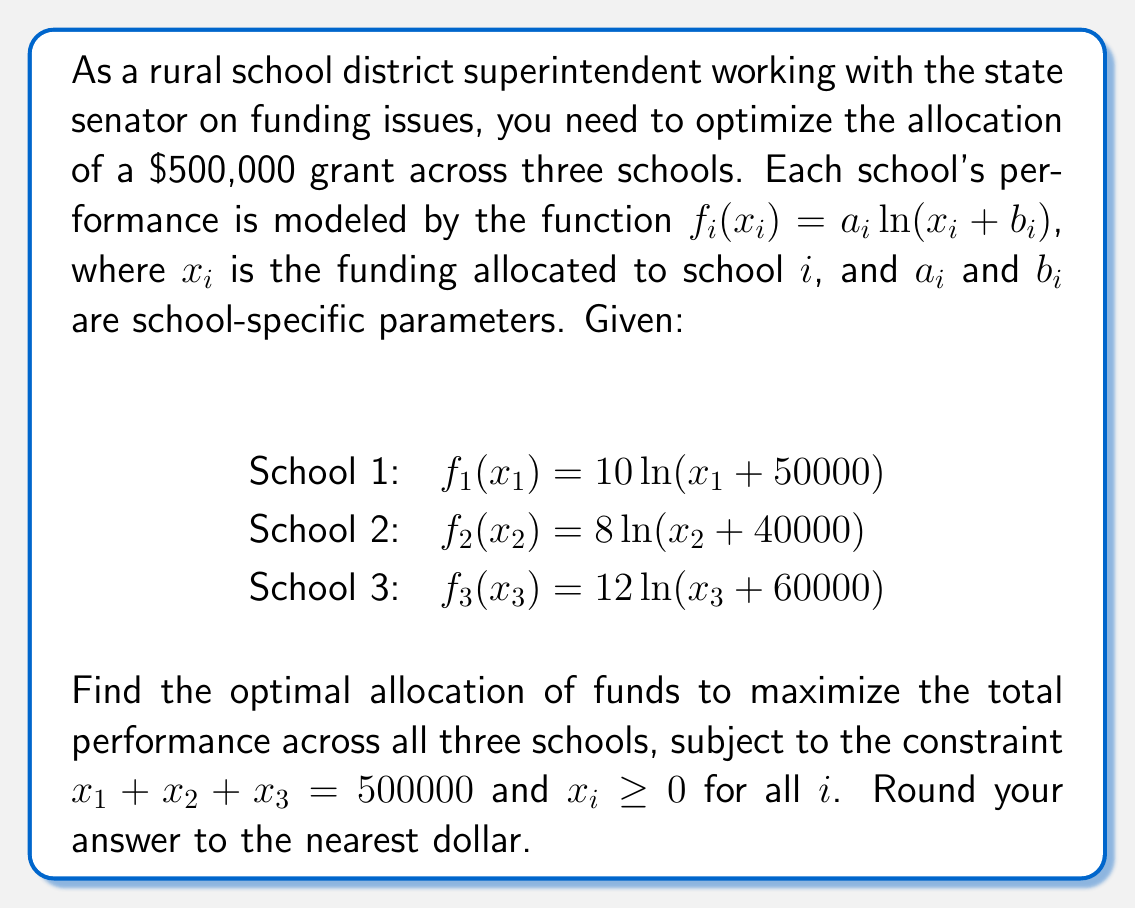Give your solution to this math problem. To solve this optimization problem, we'll use the method of Lagrange multipliers:

1) Let's define our objective function:
   $$F(x_1, x_2, x_3) = 10\ln(x_1 + 50000) + 8\ln(x_2 + 40000) + 12\ln(x_3 + 60000)$$

2) Our constraint is:
   $$g(x_1, x_2, x_3) = x_1 + x_2 + x_3 - 500000 = 0$$

3) We form the Lagrangian:
   $$L(x_1, x_2, x_3, \lambda) = F(x_1, x_2, x_3) - \lambda g(x_1, x_2, x_3)$$

4) We take partial derivatives and set them to zero:
   $$\frac{\partial L}{\partial x_1} = \frac{10}{x_1 + 50000} - \lambda = 0$$
   $$\frac{\partial L}{\partial x_2} = \frac{8}{x_2 + 40000} - \lambda = 0$$
   $$\frac{\partial L}{\partial x_3} = \frac{12}{x_3 + 60000} - \lambda = 0$$
   $$\frac{\partial L}{\partial \lambda} = x_1 + x_2 + x_3 - 500000 = 0$$

5) From these equations, we can deduce:
   $$\frac{10}{x_1 + 50000} = \frac{8}{x_2 + 40000} = \frac{12}{x_3 + 60000} = \lambda$$

6) Let's call this common value $k$. Then:
   $$x_1 + 50000 = \frac{10}{k}$$
   $$x_2 + 40000 = \frac{8}{k}$$
   $$x_3 + 60000 = \frac{12}{k}$$

7) Substituting into our constraint:
   $$(\frac{10}{k} - 50000) + (\frac{8}{k} - 40000) + (\frac{12}{k} - 60000) = 500000$$
   $$\frac{30}{k} - 150000 = 500000$$
   $$\frac{30}{k} = 650000$$
   $$k = \frac{30}{650000} = \frac{1}{21666.67}$$

8) Now we can solve for $x_1$, $x_2$, and $x_3$:
   $$x_1 = \frac{10}{k} - 50000 = 10 * 21666.67 - 50000 = 166666.67$$
   $$x_2 = \frac{8}{k} - 40000 = 8 * 21666.67 - 40000 = 133333.33$$
   $$x_3 = \frac{12}{k} - 60000 = 12 * 21666.67 - 60000 = 200000$$

9) Rounding to the nearest dollar:
   $$x_1 = 166667$$
   $$x_2 = 133333$$
   $$x_3 = 200000$$
Answer: The optimal allocation of funds is:
School 1: $166,667
School 2: $133,333
School 3: $200,000 